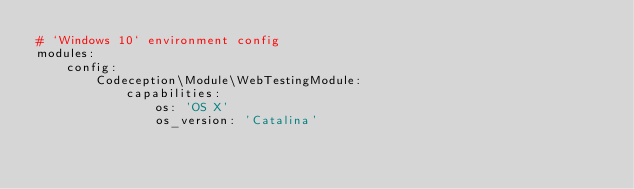<code> <loc_0><loc_0><loc_500><loc_500><_YAML_># `Windows 10` environment config
modules:
    config:
        Codeception\Module\WebTestingModule:
            capabilities:
                os: 'OS X'
                os_version: 'Catalina'
</code> 